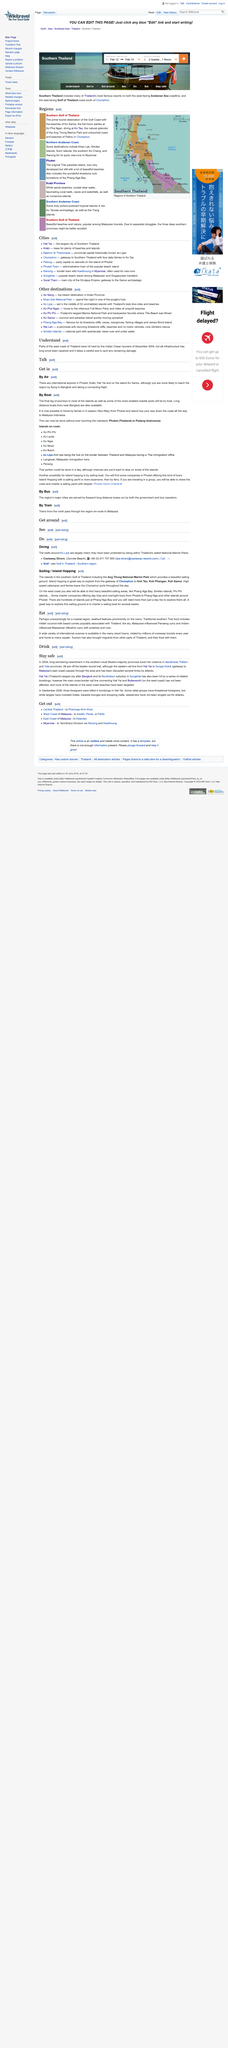Mention a couple of crucial points in this snapshot. The title of the page is "sailing/island hopping. This page is editable. Thai cuisine is renowned for its extensive use of seafood as one of its main ingredients. The limestone rock formations of Phang Nga Bay can be found in the Phuket region of Thailand. Massaman (Muslim) curry has a significant cultural influence, with its Indian origin being the primary contributor. 